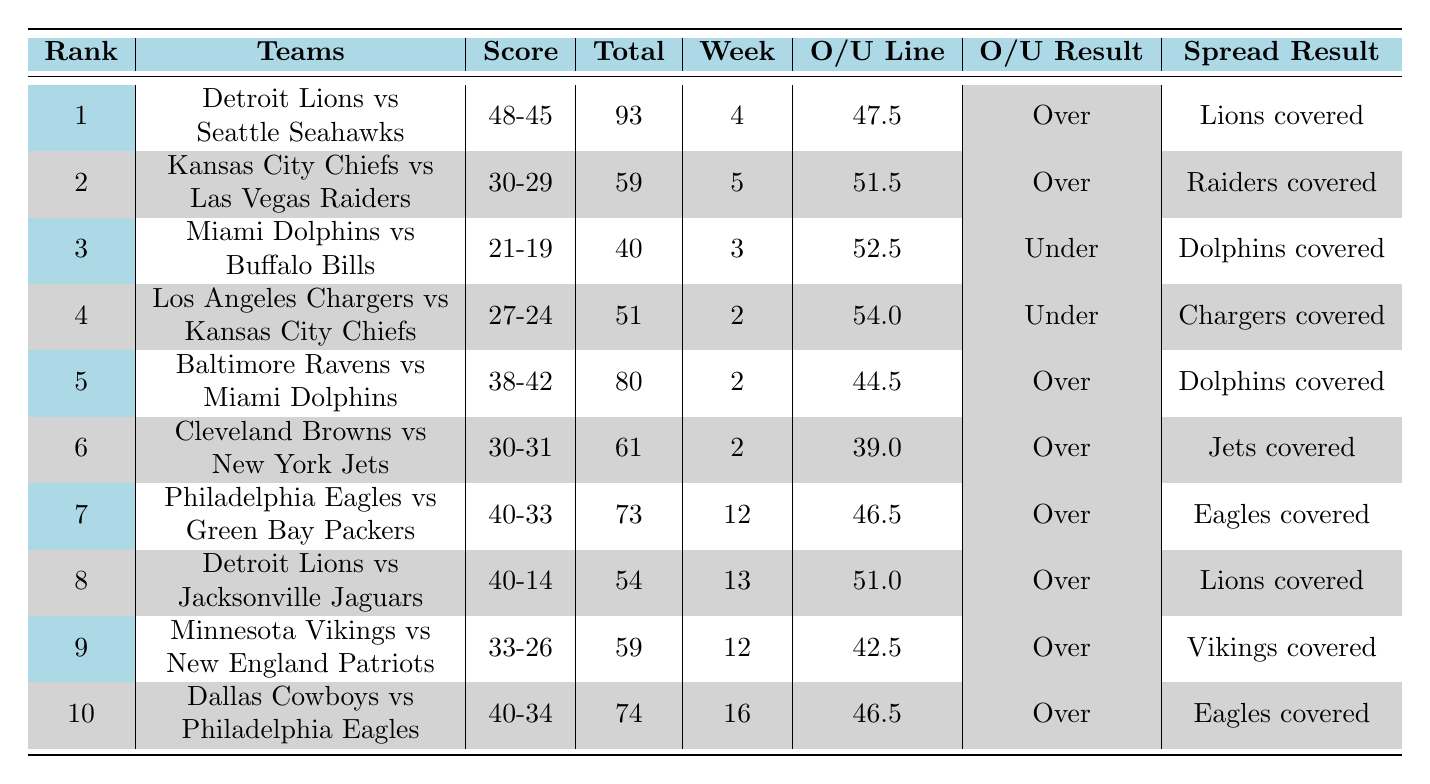What was the total points scored in the game between the Detroit Lions and Seattle Seahawks? The table shows that the score for the game was 48-45, which totals 93 points.
Answer: 93 Which week did the game between the Kansas City Chiefs and Las Vegas Raiders take place? According to the table, this game occurred in week 5.
Answer: Week 5 Did the Baltimore Ravens cover the spread against the Miami Dolphins? The table indicates that the Ravens were the favorites (-3.5), but the Dolphins covered the spread, meaning they performed better than expected against the spread.
Answer: No What is the average total points scored in the top 10 highest-scoring games? Adding up the total points from all games (93 + 59 + 40 + 51 + 80 + 61 + 73 + 54 + 59 + 74) gives a total of  718 points. Dividing this by 10 gives an average of 71.8 points.
Answer: 71.8 How many games had a total score over 60 points? By reviewing the table, the games that had total points over 60 are the games ranked 1, 2, 5, 6, 7, 10. This totals to 6 games.
Answer: 6 Which team played the most games in the top 10 highest-scoring NFL games? The table shows that the Detroit Lions appeared in two games (rank 1 and rank 8), which is more than any other team.
Answer: Detroit Lions In how many games did the total points go over the over/under line? The table indicates that there were 7 games where the total points scored went over the over/under line.
Answer: 7 Was there a game where the total score was exactly 59 points? Upon examining the table, there were two games that scored 59 points: the game between Kansas City Chiefs vs. Las Vegas Raiders and Minnesota Vikings vs. New England Patriots.
Answer: Yes What was the spread for the game ranked 10? According to the table, the spread for the Dallas Cowboys vs. Philadelphia Eagles game was Cowboys -4.
Answer: Cowboys -4 How did the Philadelphia Eagles fare against the spread in their highest-scoring game? The Eagles were favored by 6.5 points against the Green Bay Packers and the table states that the Eagles covered the spread in that game.
Answer: Covered 